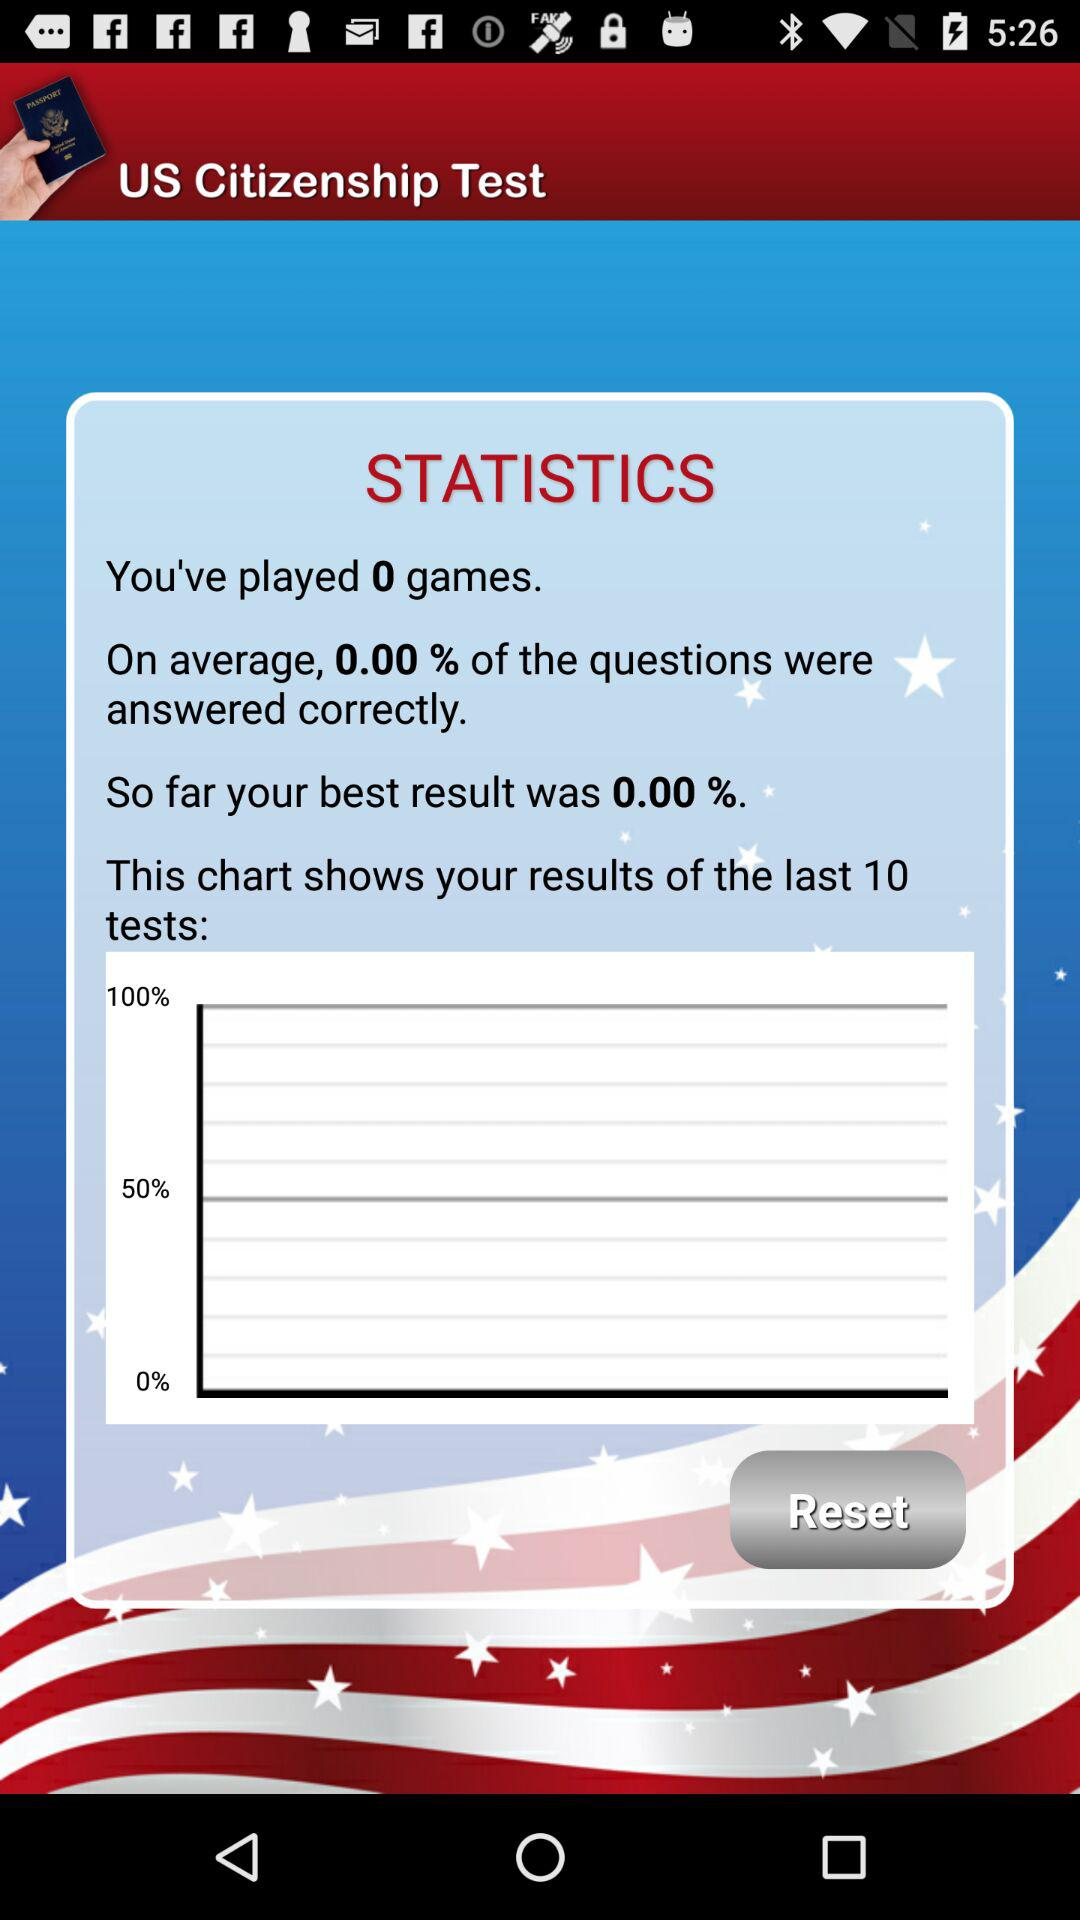On average, what percentage of questions were answered correctly? On average, the percentage of questions answered correctly was 0.00. 